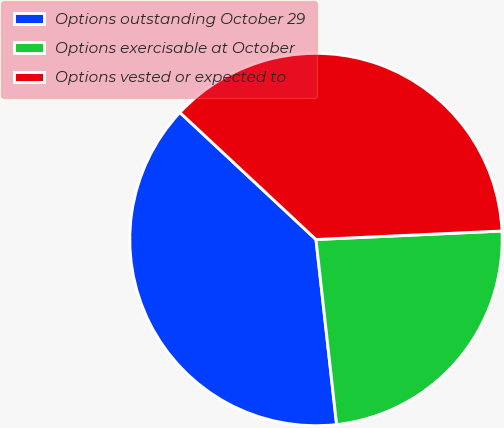<chart> <loc_0><loc_0><loc_500><loc_500><pie_chart><fcel>Options outstanding October 29<fcel>Options exercisable at October<fcel>Options vested or expected to<nl><fcel>38.72%<fcel>23.96%<fcel>37.32%<nl></chart> 